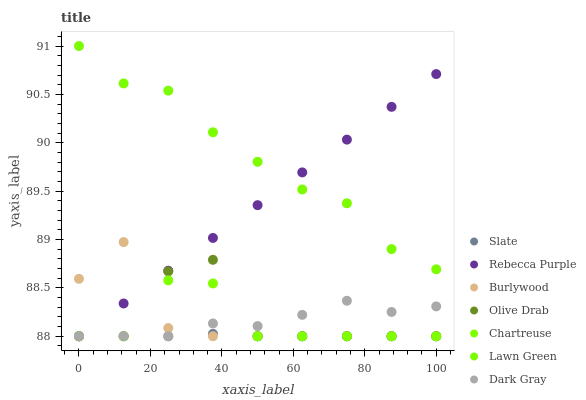Does Slate have the minimum area under the curve?
Answer yes or no. Yes. Does Lawn Green have the maximum area under the curve?
Answer yes or no. Yes. Does Burlywood have the minimum area under the curve?
Answer yes or no. No. Does Burlywood have the maximum area under the curve?
Answer yes or no. No. Is Rebecca Purple the smoothest?
Answer yes or no. Yes. Is Olive Drab the roughest?
Answer yes or no. Yes. Is Burlywood the smoothest?
Answer yes or no. No. Is Burlywood the roughest?
Answer yes or no. No. Does Burlywood have the lowest value?
Answer yes or no. Yes. Does Lawn Green have the highest value?
Answer yes or no. Yes. Does Burlywood have the highest value?
Answer yes or no. No. Is Chartreuse less than Lawn Green?
Answer yes or no. Yes. Is Lawn Green greater than Slate?
Answer yes or no. Yes. Does Olive Drab intersect Slate?
Answer yes or no. Yes. Is Olive Drab less than Slate?
Answer yes or no. No. Is Olive Drab greater than Slate?
Answer yes or no. No. Does Chartreuse intersect Lawn Green?
Answer yes or no. No. 